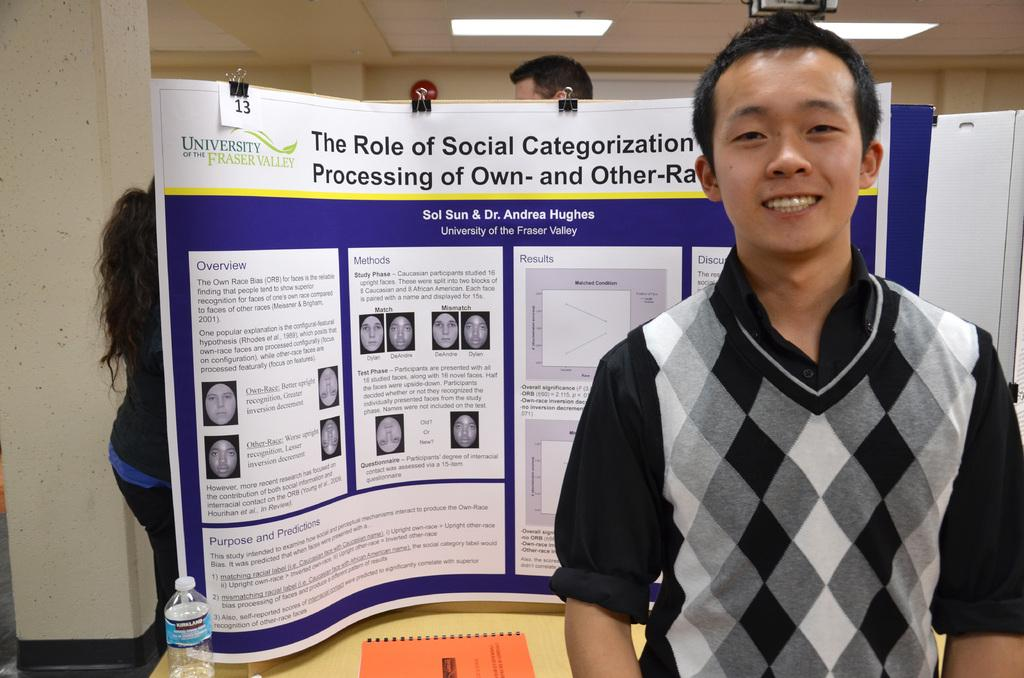<image>
Create a compact narrative representing the image presented. A man stands in front of a poster titled The Role of Social Categorization. 